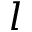Convert formula to latex. <formula><loc_0><loc_0><loc_500><loc_500>l</formula> 